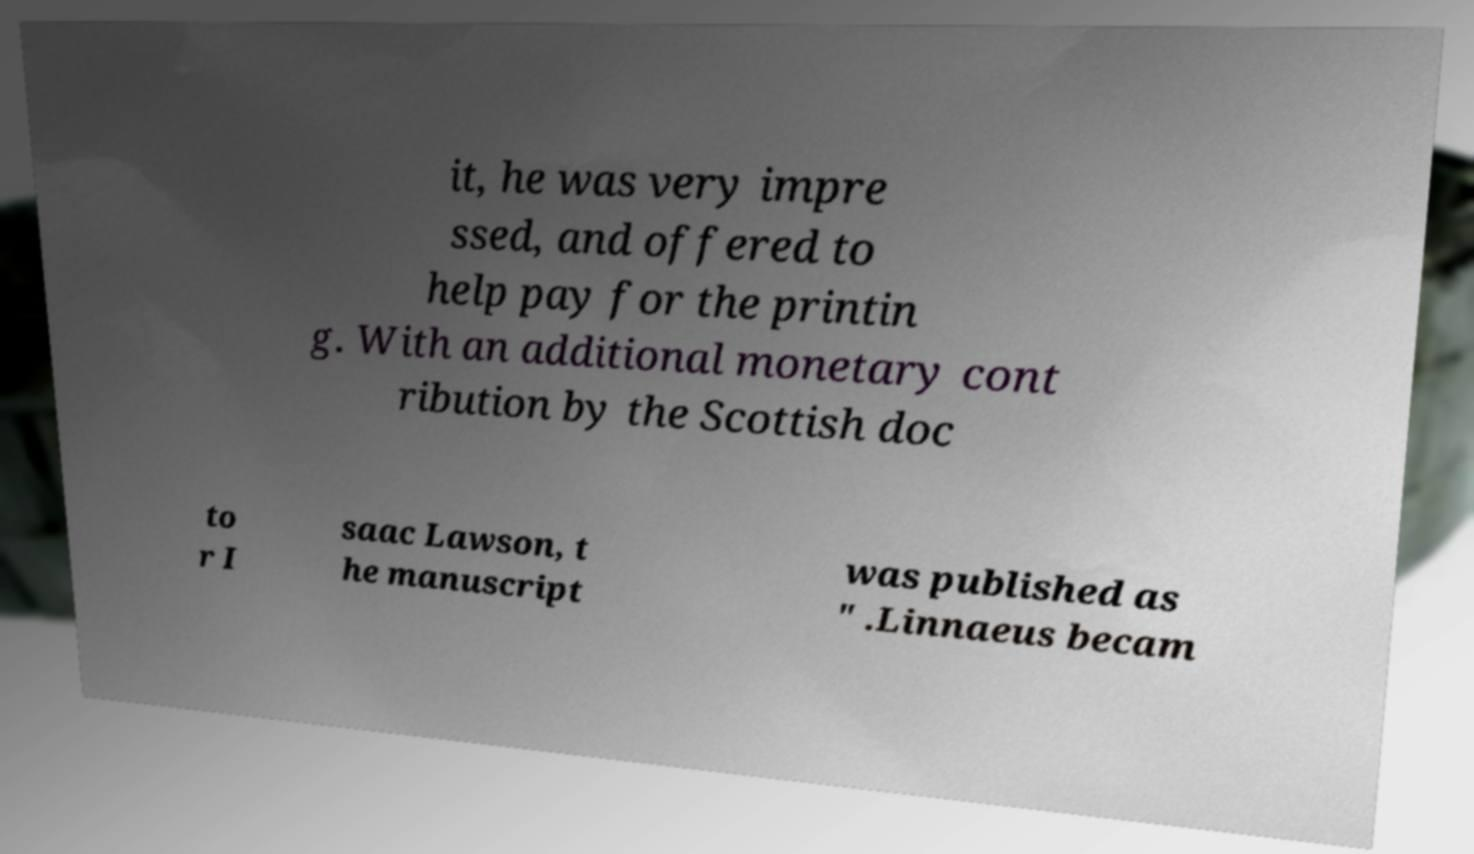Can you read and provide the text displayed in the image?This photo seems to have some interesting text. Can you extract and type it out for me? it, he was very impre ssed, and offered to help pay for the printin g. With an additional monetary cont ribution by the Scottish doc to r I saac Lawson, t he manuscript was published as " .Linnaeus becam 